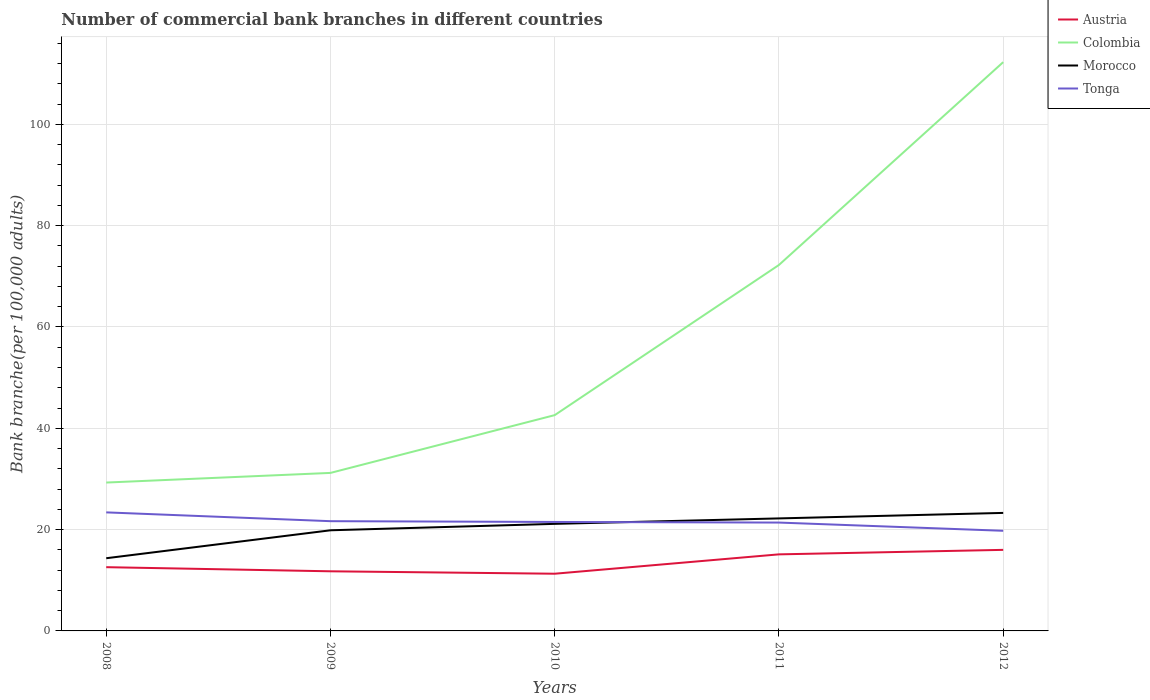How many different coloured lines are there?
Ensure brevity in your answer.  4. Across all years, what is the maximum number of commercial bank branches in Tonga?
Give a very brief answer. 19.77. In which year was the number of commercial bank branches in Colombia maximum?
Your answer should be compact. 2008. What is the total number of commercial bank branches in Morocco in the graph?
Your answer should be very brief. -5.51. What is the difference between the highest and the second highest number of commercial bank branches in Colombia?
Offer a very short reply. 82.98. What is the difference between the highest and the lowest number of commercial bank branches in Morocco?
Your answer should be compact. 3. How many lines are there?
Provide a short and direct response. 4. What is the difference between two consecutive major ticks on the Y-axis?
Make the answer very short. 20. Does the graph contain grids?
Provide a succinct answer. Yes. Where does the legend appear in the graph?
Provide a short and direct response. Top right. How are the legend labels stacked?
Offer a terse response. Vertical. What is the title of the graph?
Keep it short and to the point. Number of commercial bank branches in different countries. What is the label or title of the X-axis?
Your response must be concise. Years. What is the label or title of the Y-axis?
Your response must be concise. Bank branche(per 100,0 adults). What is the Bank branche(per 100,000 adults) of Austria in 2008?
Your answer should be very brief. 12.58. What is the Bank branche(per 100,000 adults) in Colombia in 2008?
Your response must be concise. 29.29. What is the Bank branche(per 100,000 adults) of Morocco in 2008?
Keep it short and to the point. 14.35. What is the Bank branche(per 100,000 adults) in Tonga in 2008?
Offer a very short reply. 23.4. What is the Bank branche(per 100,000 adults) of Austria in 2009?
Your answer should be very brief. 11.77. What is the Bank branche(per 100,000 adults) in Colombia in 2009?
Your answer should be compact. 31.19. What is the Bank branche(per 100,000 adults) of Morocco in 2009?
Provide a succinct answer. 19.86. What is the Bank branche(per 100,000 adults) in Tonga in 2009?
Offer a very short reply. 21.66. What is the Bank branche(per 100,000 adults) in Austria in 2010?
Your response must be concise. 11.29. What is the Bank branche(per 100,000 adults) of Colombia in 2010?
Your answer should be compact. 42.59. What is the Bank branche(per 100,000 adults) of Morocco in 2010?
Your response must be concise. 21.13. What is the Bank branche(per 100,000 adults) of Tonga in 2010?
Keep it short and to the point. 21.51. What is the Bank branche(per 100,000 adults) of Austria in 2011?
Your answer should be very brief. 15.11. What is the Bank branche(per 100,000 adults) of Colombia in 2011?
Your answer should be very brief. 72.24. What is the Bank branche(per 100,000 adults) in Morocco in 2011?
Your answer should be compact. 22.21. What is the Bank branche(per 100,000 adults) in Tonga in 2011?
Your answer should be very brief. 21.39. What is the Bank branche(per 100,000 adults) of Austria in 2012?
Your answer should be very brief. 16. What is the Bank branche(per 100,000 adults) in Colombia in 2012?
Offer a very short reply. 112.26. What is the Bank branche(per 100,000 adults) in Morocco in 2012?
Offer a terse response. 23.29. What is the Bank branche(per 100,000 adults) of Tonga in 2012?
Keep it short and to the point. 19.77. Across all years, what is the maximum Bank branche(per 100,000 adults) of Austria?
Provide a succinct answer. 16. Across all years, what is the maximum Bank branche(per 100,000 adults) of Colombia?
Provide a succinct answer. 112.26. Across all years, what is the maximum Bank branche(per 100,000 adults) in Morocco?
Provide a short and direct response. 23.29. Across all years, what is the maximum Bank branche(per 100,000 adults) in Tonga?
Ensure brevity in your answer.  23.4. Across all years, what is the minimum Bank branche(per 100,000 adults) in Austria?
Give a very brief answer. 11.29. Across all years, what is the minimum Bank branche(per 100,000 adults) in Colombia?
Keep it short and to the point. 29.29. Across all years, what is the minimum Bank branche(per 100,000 adults) in Morocco?
Give a very brief answer. 14.35. Across all years, what is the minimum Bank branche(per 100,000 adults) in Tonga?
Make the answer very short. 19.77. What is the total Bank branche(per 100,000 adults) of Austria in the graph?
Offer a very short reply. 66.76. What is the total Bank branche(per 100,000 adults) of Colombia in the graph?
Your answer should be compact. 287.57. What is the total Bank branche(per 100,000 adults) in Morocco in the graph?
Your answer should be very brief. 100.85. What is the total Bank branche(per 100,000 adults) in Tonga in the graph?
Give a very brief answer. 107.72. What is the difference between the Bank branche(per 100,000 adults) of Austria in 2008 and that in 2009?
Offer a terse response. 0.82. What is the difference between the Bank branche(per 100,000 adults) of Colombia in 2008 and that in 2009?
Provide a succinct answer. -1.9. What is the difference between the Bank branche(per 100,000 adults) in Morocco in 2008 and that in 2009?
Your answer should be very brief. -5.51. What is the difference between the Bank branche(per 100,000 adults) of Tonga in 2008 and that in 2009?
Provide a succinct answer. 1.74. What is the difference between the Bank branche(per 100,000 adults) of Austria in 2008 and that in 2010?
Your response must be concise. 1.29. What is the difference between the Bank branche(per 100,000 adults) of Colombia in 2008 and that in 2010?
Your response must be concise. -13.31. What is the difference between the Bank branche(per 100,000 adults) of Morocco in 2008 and that in 2010?
Provide a short and direct response. -6.78. What is the difference between the Bank branche(per 100,000 adults) in Tonga in 2008 and that in 2010?
Ensure brevity in your answer.  1.89. What is the difference between the Bank branche(per 100,000 adults) in Austria in 2008 and that in 2011?
Your response must be concise. -2.53. What is the difference between the Bank branche(per 100,000 adults) of Colombia in 2008 and that in 2011?
Your answer should be very brief. -42.95. What is the difference between the Bank branche(per 100,000 adults) of Morocco in 2008 and that in 2011?
Give a very brief answer. -7.86. What is the difference between the Bank branche(per 100,000 adults) of Tonga in 2008 and that in 2011?
Offer a terse response. 2.01. What is the difference between the Bank branche(per 100,000 adults) of Austria in 2008 and that in 2012?
Provide a succinct answer. -3.42. What is the difference between the Bank branche(per 100,000 adults) in Colombia in 2008 and that in 2012?
Offer a terse response. -82.98. What is the difference between the Bank branche(per 100,000 adults) in Morocco in 2008 and that in 2012?
Your answer should be compact. -8.94. What is the difference between the Bank branche(per 100,000 adults) of Tonga in 2008 and that in 2012?
Offer a terse response. 3.63. What is the difference between the Bank branche(per 100,000 adults) of Austria in 2009 and that in 2010?
Keep it short and to the point. 0.48. What is the difference between the Bank branche(per 100,000 adults) in Colombia in 2009 and that in 2010?
Your answer should be very brief. -11.4. What is the difference between the Bank branche(per 100,000 adults) in Morocco in 2009 and that in 2010?
Give a very brief answer. -1.27. What is the difference between the Bank branche(per 100,000 adults) of Tonga in 2009 and that in 2010?
Give a very brief answer. 0.15. What is the difference between the Bank branche(per 100,000 adults) of Austria in 2009 and that in 2011?
Your response must be concise. -3.35. What is the difference between the Bank branche(per 100,000 adults) in Colombia in 2009 and that in 2011?
Make the answer very short. -41.05. What is the difference between the Bank branche(per 100,000 adults) of Morocco in 2009 and that in 2011?
Make the answer very short. -2.35. What is the difference between the Bank branche(per 100,000 adults) in Tonga in 2009 and that in 2011?
Provide a short and direct response. 0.27. What is the difference between the Bank branche(per 100,000 adults) in Austria in 2009 and that in 2012?
Offer a terse response. -4.23. What is the difference between the Bank branche(per 100,000 adults) of Colombia in 2009 and that in 2012?
Offer a very short reply. -81.07. What is the difference between the Bank branche(per 100,000 adults) of Morocco in 2009 and that in 2012?
Offer a very short reply. -3.43. What is the difference between the Bank branche(per 100,000 adults) of Tonga in 2009 and that in 2012?
Provide a succinct answer. 1.89. What is the difference between the Bank branche(per 100,000 adults) in Austria in 2010 and that in 2011?
Offer a terse response. -3.82. What is the difference between the Bank branche(per 100,000 adults) of Colombia in 2010 and that in 2011?
Give a very brief answer. -29.64. What is the difference between the Bank branche(per 100,000 adults) in Morocco in 2010 and that in 2011?
Make the answer very short. -1.08. What is the difference between the Bank branche(per 100,000 adults) in Tonga in 2010 and that in 2011?
Your response must be concise. 0.12. What is the difference between the Bank branche(per 100,000 adults) in Austria in 2010 and that in 2012?
Your answer should be very brief. -4.71. What is the difference between the Bank branche(per 100,000 adults) of Colombia in 2010 and that in 2012?
Your answer should be very brief. -69.67. What is the difference between the Bank branche(per 100,000 adults) of Morocco in 2010 and that in 2012?
Provide a succinct answer. -2.16. What is the difference between the Bank branche(per 100,000 adults) of Tonga in 2010 and that in 2012?
Your answer should be very brief. 1.74. What is the difference between the Bank branche(per 100,000 adults) of Austria in 2011 and that in 2012?
Your answer should be compact. -0.89. What is the difference between the Bank branche(per 100,000 adults) in Colombia in 2011 and that in 2012?
Keep it short and to the point. -40.03. What is the difference between the Bank branche(per 100,000 adults) in Morocco in 2011 and that in 2012?
Your answer should be very brief. -1.08. What is the difference between the Bank branche(per 100,000 adults) of Tonga in 2011 and that in 2012?
Your answer should be very brief. 1.62. What is the difference between the Bank branche(per 100,000 adults) of Austria in 2008 and the Bank branche(per 100,000 adults) of Colombia in 2009?
Provide a short and direct response. -18.61. What is the difference between the Bank branche(per 100,000 adults) of Austria in 2008 and the Bank branche(per 100,000 adults) of Morocco in 2009?
Your answer should be very brief. -7.28. What is the difference between the Bank branche(per 100,000 adults) of Austria in 2008 and the Bank branche(per 100,000 adults) of Tonga in 2009?
Your answer should be compact. -9.08. What is the difference between the Bank branche(per 100,000 adults) of Colombia in 2008 and the Bank branche(per 100,000 adults) of Morocco in 2009?
Provide a succinct answer. 9.42. What is the difference between the Bank branche(per 100,000 adults) of Colombia in 2008 and the Bank branche(per 100,000 adults) of Tonga in 2009?
Keep it short and to the point. 7.63. What is the difference between the Bank branche(per 100,000 adults) in Morocco in 2008 and the Bank branche(per 100,000 adults) in Tonga in 2009?
Provide a succinct answer. -7.31. What is the difference between the Bank branche(per 100,000 adults) in Austria in 2008 and the Bank branche(per 100,000 adults) in Colombia in 2010?
Keep it short and to the point. -30.01. What is the difference between the Bank branche(per 100,000 adults) in Austria in 2008 and the Bank branche(per 100,000 adults) in Morocco in 2010?
Give a very brief answer. -8.55. What is the difference between the Bank branche(per 100,000 adults) of Austria in 2008 and the Bank branche(per 100,000 adults) of Tonga in 2010?
Your response must be concise. -8.92. What is the difference between the Bank branche(per 100,000 adults) in Colombia in 2008 and the Bank branche(per 100,000 adults) in Morocco in 2010?
Offer a very short reply. 8.16. What is the difference between the Bank branche(per 100,000 adults) in Colombia in 2008 and the Bank branche(per 100,000 adults) in Tonga in 2010?
Keep it short and to the point. 7.78. What is the difference between the Bank branche(per 100,000 adults) in Morocco in 2008 and the Bank branche(per 100,000 adults) in Tonga in 2010?
Keep it short and to the point. -7.16. What is the difference between the Bank branche(per 100,000 adults) of Austria in 2008 and the Bank branche(per 100,000 adults) of Colombia in 2011?
Your answer should be compact. -59.65. What is the difference between the Bank branche(per 100,000 adults) in Austria in 2008 and the Bank branche(per 100,000 adults) in Morocco in 2011?
Your response must be concise. -9.62. What is the difference between the Bank branche(per 100,000 adults) in Austria in 2008 and the Bank branche(per 100,000 adults) in Tonga in 2011?
Your answer should be compact. -8.8. What is the difference between the Bank branche(per 100,000 adults) of Colombia in 2008 and the Bank branche(per 100,000 adults) of Morocco in 2011?
Your response must be concise. 7.08. What is the difference between the Bank branche(per 100,000 adults) in Colombia in 2008 and the Bank branche(per 100,000 adults) in Tonga in 2011?
Give a very brief answer. 7.9. What is the difference between the Bank branche(per 100,000 adults) in Morocco in 2008 and the Bank branche(per 100,000 adults) in Tonga in 2011?
Give a very brief answer. -7.04. What is the difference between the Bank branche(per 100,000 adults) of Austria in 2008 and the Bank branche(per 100,000 adults) of Colombia in 2012?
Provide a short and direct response. -99.68. What is the difference between the Bank branche(per 100,000 adults) of Austria in 2008 and the Bank branche(per 100,000 adults) of Morocco in 2012?
Offer a very short reply. -10.71. What is the difference between the Bank branche(per 100,000 adults) of Austria in 2008 and the Bank branche(per 100,000 adults) of Tonga in 2012?
Provide a succinct answer. -7.18. What is the difference between the Bank branche(per 100,000 adults) in Colombia in 2008 and the Bank branche(per 100,000 adults) in Morocco in 2012?
Offer a very short reply. 5.99. What is the difference between the Bank branche(per 100,000 adults) in Colombia in 2008 and the Bank branche(per 100,000 adults) in Tonga in 2012?
Make the answer very short. 9.52. What is the difference between the Bank branche(per 100,000 adults) of Morocco in 2008 and the Bank branche(per 100,000 adults) of Tonga in 2012?
Provide a short and direct response. -5.42. What is the difference between the Bank branche(per 100,000 adults) of Austria in 2009 and the Bank branche(per 100,000 adults) of Colombia in 2010?
Give a very brief answer. -30.83. What is the difference between the Bank branche(per 100,000 adults) of Austria in 2009 and the Bank branche(per 100,000 adults) of Morocco in 2010?
Your answer should be very brief. -9.36. What is the difference between the Bank branche(per 100,000 adults) of Austria in 2009 and the Bank branche(per 100,000 adults) of Tonga in 2010?
Your response must be concise. -9.74. What is the difference between the Bank branche(per 100,000 adults) in Colombia in 2009 and the Bank branche(per 100,000 adults) in Morocco in 2010?
Offer a very short reply. 10.06. What is the difference between the Bank branche(per 100,000 adults) of Colombia in 2009 and the Bank branche(per 100,000 adults) of Tonga in 2010?
Keep it short and to the point. 9.68. What is the difference between the Bank branche(per 100,000 adults) in Morocco in 2009 and the Bank branche(per 100,000 adults) in Tonga in 2010?
Offer a terse response. -1.65. What is the difference between the Bank branche(per 100,000 adults) of Austria in 2009 and the Bank branche(per 100,000 adults) of Colombia in 2011?
Give a very brief answer. -60.47. What is the difference between the Bank branche(per 100,000 adults) of Austria in 2009 and the Bank branche(per 100,000 adults) of Morocco in 2011?
Give a very brief answer. -10.44. What is the difference between the Bank branche(per 100,000 adults) of Austria in 2009 and the Bank branche(per 100,000 adults) of Tonga in 2011?
Make the answer very short. -9.62. What is the difference between the Bank branche(per 100,000 adults) in Colombia in 2009 and the Bank branche(per 100,000 adults) in Morocco in 2011?
Ensure brevity in your answer.  8.98. What is the difference between the Bank branche(per 100,000 adults) of Colombia in 2009 and the Bank branche(per 100,000 adults) of Tonga in 2011?
Offer a terse response. 9.8. What is the difference between the Bank branche(per 100,000 adults) of Morocco in 2009 and the Bank branche(per 100,000 adults) of Tonga in 2011?
Your answer should be compact. -1.52. What is the difference between the Bank branche(per 100,000 adults) in Austria in 2009 and the Bank branche(per 100,000 adults) in Colombia in 2012?
Your response must be concise. -100.5. What is the difference between the Bank branche(per 100,000 adults) in Austria in 2009 and the Bank branche(per 100,000 adults) in Morocco in 2012?
Your response must be concise. -11.53. What is the difference between the Bank branche(per 100,000 adults) of Austria in 2009 and the Bank branche(per 100,000 adults) of Tonga in 2012?
Your response must be concise. -8. What is the difference between the Bank branche(per 100,000 adults) in Colombia in 2009 and the Bank branche(per 100,000 adults) in Morocco in 2012?
Make the answer very short. 7.9. What is the difference between the Bank branche(per 100,000 adults) in Colombia in 2009 and the Bank branche(per 100,000 adults) in Tonga in 2012?
Give a very brief answer. 11.42. What is the difference between the Bank branche(per 100,000 adults) in Morocco in 2009 and the Bank branche(per 100,000 adults) in Tonga in 2012?
Keep it short and to the point. 0.1. What is the difference between the Bank branche(per 100,000 adults) in Austria in 2010 and the Bank branche(per 100,000 adults) in Colombia in 2011?
Offer a terse response. -60.95. What is the difference between the Bank branche(per 100,000 adults) in Austria in 2010 and the Bank branche(per 100,000 adults) in Morocco in 2011?
Your answer should be very brief. -10.92. What is the difference between the Bank branche(per 100,000 adults) of Austria in 2010 and the Bank branche(per 100,000 adults) of Tonga in 2011?
Your answer should be very brief. -10.1. What is the difference between the Bank branche(per 100,000 adults) in Colombia in 2010 and the Bank branche(per 100,000 adults) in Morocco in 2011?
Keep it short and to the point. 20.38. What is the difference between the Bank branche(per 100,000 adults) of Colombia in 2010 and the Bank branche(per 100,000 adults) of Tonga in 2011?
Provide a succinct answer. 21.21. What is the difference between the Bank branche(per 100,000 adults) of Morocco in 2010 and the Bank branche(per 100,000 adults) of Tonga in 2011?
Offer a very short reply. -0.26. What is the difference between the Bank branche(per 100,000 adults) of Austria in 2010 and the Bank branche(per 100,000 adults) of Colombia in 2012?
Offer a terse response. -100.97. What is the difference between the Bank branche(per 100,000 adults) in Austria in 2010 and the Bank branche(per 100,000 adults) in Morocco in 2012?
Give a very brief answer. -12. What is the difference between the Bank branche(per 100,000 adults) in Austria in 2010 and the Bank branche(per 100,000 adults) in Tonga in 2012?
Provide a succinct answer. -8.48. What is the difference between the Bank branche(per 100,000 adults) in Colombia in 2010 and the Bank branche(per 100,000 adults) in Morocco in 2012?
Provide a short and direct response. 19.3. What is the difference between the Bank branche(per 100,000 adults) of Colombia in 2010 and the Bank branche(per 100,000 adults) of Tonga in 2012?
Your answer should be very brief. 22.83. What is the difference between the Bank branche(per 100,000 adults) of Morocco in 2010 and the Bank branche(per 100,000 adults) of Tonga in 2012?
Provide a short and direct response. 1.36. What is the difference between the Bank branche(per 100,000 adults) in Austria in 2011 and the Bank branche(per 100,000 adults) in Colombia in 2012?
Make the answer very short. -97.15. What is the difference between the Bank branche(per 100,000 adults) in Austria in 2011 and the Bank branche(per 100,000 adults) in Morocco in 2012?
Ensure brevity in your answer.  -8.18. What is the difference between the Bank branche(per 100,000 adults) of Austria in 2011 and the Bank branche(per 100,000 adults) of Tonga in 2012?
Offer a terse response. -4.65. What is the difference between the Bank branche(per 100,000 adults) in Colombia in 2011 and the Bank branche(per 100,000 adults) in Morocco in 2012?
Keep it short and to the point. 48.94. What is the difference between the Bank branche(per 100,000 adults) in Colombia in 2011 and the Bank branche(per 100,000 adults) in Tonga in 2012?
Your answer should be compact. 52.47. What is the difference between the Bank branche(per 100,000 adults) in Morocco in 2011 and the Bank branche(per 100,000 adults) in Tonga in 2012?
Provide a short and direct response. 2.44. What is the average Bank branche(per 100,000 adults) of Austria per year?
Your answer should be very brief. 13.35. What is the average Bank branche(per 100,000 adults) of Colombia per year?
Ensure brevity in your answer.  57.51. What is the average Bank branche(per 100,000 adults) of Morocco per year?
Give a very brief answer. 20.17. What is the average Bank branche(per 100,000 adults) of Tonga per year?
Give a very brief answer. 21.54. In the year 2008, what is the difference between the Bank branche(per 100,000 adults) in Austria and Bank branche(per 100,000 adults) in Colombia?
Your answer should be compact. -16.7. In the year 2008, what is the difference between the Bank branche(per 100,000 adults) in Austria and Bank branche(per 100,000 adults) in Morocco?
Offer a very short reply. -1.76. In the year 2008, what is the difference between the Bank branche(per 100,000 adults) of Austria and Bank branche(per 100,000 adults) of Tonga?
Your answer should be compact. -10.81. In the year 2008, what is the difference between the Bank branche(per 100,000 adults) of Colombia and Bank branche(per 100,000 adults) of Morocco?
Provide a succinct answer. 14.94. In the year 2008, what is the difference between the Bank branche(per 100,000 adults) of Colombia and Bank branche(per 100,000 adults) of Tonga?
Give a very brief answer. 5.89. In the year 2008, what is the difference between the Bank branche(per 100,000 adults) of Morocco and Bank branche(per 100,000 adults) of Tonga?
Your response must be concise. -9.05. In the year 2009, what is the difference between the Bank branche(per 100,000 adults) in Austria and Bank branche(per 100,000 adults) in Colombia?
Offer a terse response. -19.42. In the year 2009, what is the difference between the Bank branche(per 100,000 adults) in Austria and Bank branche(per 100,000 adults) in Morocco?
Offer a very short reply. -8.1. In the year 2009, what is the difference between the Bank branche(per 100,000 adults) in Austria and Bank branche(per 100,000 adults) in Tonga?
Provide a succinct answer. -9.89. In the year 2009, what is the difference between the Bank branche(per 100,000 adults) in Colombia and Bank branche(per 100,000 adults) in Morocco?
Provide a succinct answer. 11.33. In the year 2009, what is the difference between the Bank branche(per 100,000 adults) of Colombia and Bank branche(per 100,000 adults) of Tonga?
Ensure brevity in your answer.  9.53. In the year 2009, what is the difference between the Bank branche(per 100,000 adults) of Morocco and Bank branche(per 100,000 adults) of Tonga?
Provide a succinct answer. -1.8. In the year 2010, what is the difference between the Bank branche(per 100,000 adults) of Austria and Bank branche(per 100,000 adults) of Colombia?
Provide a short and direct response. -31.3. In the year 2010, what is the difference between the Bank branche(per 100,000 adults) of Austria and Bank branche(per 100,000 adults) of Morocco?
Ensure brevity in your answer.  -9.84. In the year 2010, what is the difference between the Bank branche(per 100,000 adults) of Austria and Bank branche(per 100,000 adults) of Tonga?
Provide a succinct answer. -10.22. In the year 2010, what is the difference between the Bank branche(per 100,000 adults) in Colombia and Bank branche(per 100,000 adults) in Morocco?
Provide a succinct answer. 21.46. In the year 2010, what is the difference between the Bank branche(per 100,000 adults) in Colombia and Bank branche(per 100,000 adults) in Tonga?
Keep it short and to the point. 21.08. In the year 2010, what is the difference between the Bank branche(per 100,000 adults) in Morocco and Bank branche(per 100,000 adults) in Tonga?
Your answer should be very brief. -0.38. In the year 2011, what is the difference between the Bank branche(per 100,000 adults) in Austria and Bank branche(per 100,000 adults) in Colombia?
Keep it short and to the point. -57.12. In the year 2011, what is the difference between the Bank branche(per 100,000 adults) in Austria and Bank branche(per 100,000 adults) in Morocco?
Make the answer very short. -7.1. In the year 2011, what is the difference between the Bank branche(per 100,000 adults) in Austria and Bank branche(per 100,000 adults) in Tonga?
Your response must be concise. -6.27. In the year 2011, what is the difference between the Bank branche(per 100,000 adults) in Colombia and Bank branche(per 100,000 adults) in Morocco?
Provide a succinct answer. 50.03. In the year 2011, what is the difference between the Bank branche(per 100,000 adults) in Colombia and Bank branche(per 100,000 adults) in Tonga?
Give a very brief answer. 50.85. In the year 2011, what is the difference between the Bank branche(per 100,000 adults) of Morocco and Bank branche(per 100,000 adults) of Tonga?
Give a very brief answer. 0.82. In the year 2012, what is the difference between the Bank branche(per 100,000 adults) in Austria and Bank branche(per 100,000 adults) in Colombia?
Keep it short and to the point. -96.27. In the year 2012, what is the difference between the Bank branche(per 100,000 adults) in Austria and Bank branche(per 100,000 adults) in Morocco?
Your response must be concise. -7.29. In the year 2012, what is the difference between the Bank branche(per 100,000 adults) of Austria and Bank branche(per 100,000 adults) of Tonga?
Your answer should be compact. -3.77. In the year 2012, what is the difference between the Bank branche(per 100,000 adults) of Colombia and Bank branche(per 100,000 adults) of Morocco?
Ensure brevity in your answer.  88.97. In the year 2012, what is the difference between the Bank branche(per 100,000 adults) of Colombia and Bank branche(per 100,000 adults) of Tonga?
Your answer should be compact. 92.5. In the year 2012, what is the difference between the Bank branche(per 100,000 adults) of Morocco and Bank branche(per 100,000 adults) of Tonga?
Provide a succinct answer. 3.53. What is the ratio of the Bank branche(per 100,000 adults) in Austria in 2008 to that in 2009?
Offer a terse response. 1.07. What is the ratio of the Bank branche(per 100,000 adults) of Colombia in 2008 to that in 2009?
Provide a short and direct response. 0.94. What is the ratio of the Bank branche(per 100,000 adults) in Morocco in 2008 to that in 2009?
Keep it short and to the point. 0.72. What is the ratio of the Bank branche(per 100,000 adults) in Tonga in 2008 to that in 2009?
Give a very brief answer. 1.08. What is the ratio of the Bank branche(per 100,000 adults) of Austria in 2008 to that in 2010?
Offer a terse response. 1.11. What is the ratio of the Bank branche(per 100,000 adults) in Colombia in 2008 to that in 2010?
Your response must be concise. 0.69. What is the ratio of the Bank branche(per 100,000 adults) of Morocco in 2008 to that in 2010?
Provide a short and direct response. 0.68. What is the ratio of the Bank branche(per 100,000 adults) in Tonga in 2008 to that in 2010?
Ensure brevity in your answer.  1.09. What is the ratio of the Bank branche(per 100,000 adults) in Austria in 2008 to that in 2011?
Make the answer very short. 0.83. What is the ratio of the Bank branche(per 100,000 adults) of Colombia in 2008 to that in 2011?
Offer a very short reply. 0.41. What is the ratio of the Bank branche(per 100,000 adults) of Morocco in 2008 to that in 2011?
Your answer should be very brief. 0.65. What is the ratio of the Bank branche(per 100,000 adults) in Tonga in 2008 to that in 2011?
Ensure brevity in your answer.  1.09. What is the ratio of the Bank branche(per 100,000 adults) in Austria in 2008 to that in 2012?
Give a very brief answer. 0.79. What is the ratio of the Bank branche(per 100,000 adults) of Colombia in 2008 to that in 2012?
Ensure brevity in your answer.  0.26. What is the ratio of the Bank branche(per 100,000 adults) of Morocco in 2008 to that in 2012?
Give a very brief answer. 0.62. What is the ratio of the Bank branche(per 100,000 adults) of Tonga in 2008 to that in 2012?
Make the answer very short. 1.18. What is the ratio of the Bank branche(per 100,000 adults) in Austria in 2009 to that in 2010?
Give a very brief answer. 1.04. What is the ratio of the Bank branche(per 100,000 adults) in Colombia in 2009 to that in 2010?
Your answer should be very brief. 0.73. What is the ratio of the Bank branche(per 100,000 adults) in Tonga in 2009 to that in 2010?
Your answer should be compact. 1.01. What is the ratio of the Bank branche(per 100,000 adults) of Austria in 2009 to that in 2011?
Provide a short and direct response. 0.78. What is the ratio of the Bank branche(per 100,000 adults) of Colombia in 2009 to that in 2011?
Your answer should be compact. 0.43. What is the ratio of the Bank branche(per 100,000 adults) of Morocco in 2009 to that in 2011?
Keep it short and to the point. 0.89. What is the ratio of the Bank branche(per 100,000 adults) of Tonga in 2009 to that in 2011?
Keep it short and to the point. 1.01. What is the ratio of the Bank branche(per 100,000 adults) of Austria in 2009 to that in 2012?
Your response must be concise. 0.74. What is the ratio of the Bank branche(per 100,000 adults) of Colombia in 2009 to that in 2012?
Give a very brief answer. 0.28. What is the ratio of the Bank branche(per 100,000 adults) in Morocco in 2009 to that in 2012?
Offer a terse response. 0.85. What is the ratio of the Bank branche(per 100,000 adults) of Tonga in 2009 to that in 2012?
Provide a succinct answer. 1.1. What is the ratio of the Bank branche(per 100,000 adults) in Austria in 2010 to that in 2011?
Keep it short and to the point. 0.75. What is the ratio of the Bank branche(per 100,000 adults) of Colombia in 2010 to that in 2011?
Offer a terse response. 0.59. What is the ratio of the Bank branche(per 100,000 adults) in Morocco in 2010 to that in 2011?
Offer a terse response. 0.95. What is the ratio of the Bank branche(per 100,000 adults) of Austria in 2010 to that in 2012?
Give a very brief answer. 0.71. What is the ratio of the Bank branche(per 100,000 adults) of Colombia in 2010 to that in 2012?
Ensure brevity in your answer.  0.38. What is the ratio of the Bank branche(per 100,000 adults) in Morocco in 2010 to that in 2012?
Your answer should be very brief. 0.91. What is the ratio of the Bank branche(per 100,000 adults) of Tonga in 2010 to that in 2012?
Your answer should be compact. 1.09. What is the ratio of the Bank branche(per 100,000 adults) of Austria in 2011 to that in 2012?
Offer a terse response. 0.94. What is the ratio of the Bank branche(per 100,000 adults) of Colombia in 2011 to that in 2012?
Make the answer very short. 0.64. What is the ratio of the Bank branche(per 100,000 adults) in Morocco in 2011 to that in 2012?
Offer a very short reply. 0.95. What is the ratio of the Bank branche(per 100,000 adults) of Tonga in 2011 to that in 2012?
Keep it short and to the point. 1.08. What is the difference between the highest and the second highest Bank branche(per 100,000 adults) of Austria?
Ensure brevity in your answer.  0.89. What is the difference between the highest and the second highest Bank branche(per 100,000 adults) of Colombia?
Keep it short and to the point. 40.03. What is the difference between the highest and the second highest Bank branche(per 100,000 adults) in Morocco?
Provide a short and direct response. 1.08. What is the difference between the highest and the second highest Bank branche(per 100,000 adults) of Tonga?
Keep it short and to the point. 1.74. What is the difference between the highest and the lowest Bank branche(per 100,000 adults) of Austria?
Your answer should be very brief. 4.71. What is the difference between the highest and the lowest Bank branche(per 100,000 adults) in Colombia?
Provide a short and direct response. 82.98. What is the difference between the highest and the lowest Bank branche(per 100,000 adults) in Morocco?
Provide a succinct answer. 8.94. What is the difference between the highest and the lowest Bank branche(per 100,000 adults) of Tonga?
Your answer should be very brief. 3.63. 